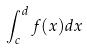<formula> <loc_0><loc_0><loc_500><loc_500>\int _ { c } ^ { d } f ( x ) d x</formula> 